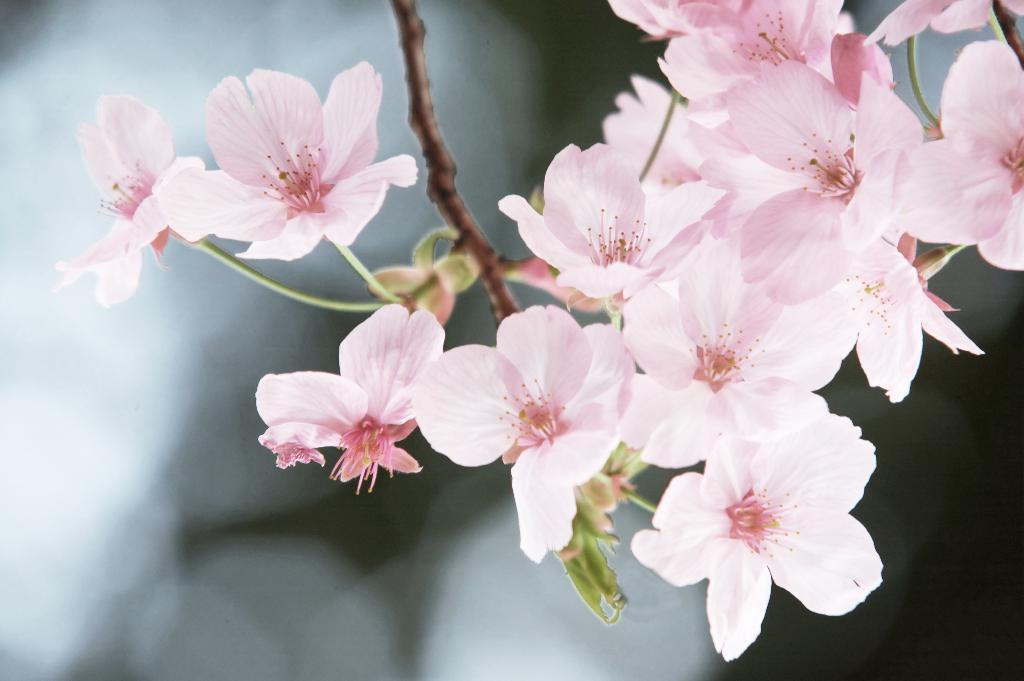Describe this image in one or two sentences. This image consists of flowers in pink color. In the middle, there is a stem. At the bottom, there is a leaf. The background is blurred. 